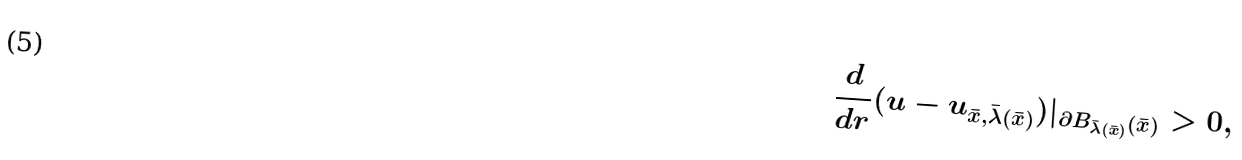<formula> <loc_0><loc_0><loc_500><loc_500>\frac { d } { d r } ( u - u _ { \bar { x } , \bar { \lambda } ( \bar { x } ) } ) | _ { \partial B _ { \bar { \lambda } ( \bar { x } ) } ( \bar { x } ) } > 0 ,</formula> 